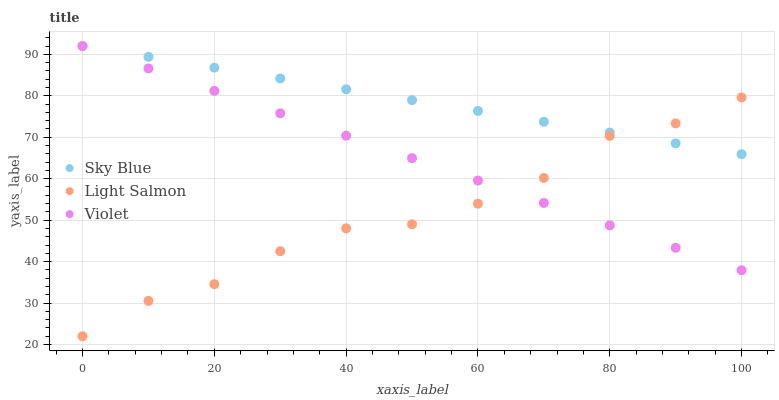Does Light Salmon have the minimum area under the curve?
Answer yes or no. Yes. Does Sky Blue have the maximum area under the curve?
Answer yes or no. Yes. Does Violet have the minimum area under the curve?
Answer yes or no. No. Does Violet have the maximum area under the curve?
Answer yes or no. No. Is Violet the smoothest?
Answer yes or no. Yes. Is Light Salmon the roughest?
Answer yes or no. Yes. Is Light Salmon the smoothest?
Answer yes or no. No. Is Violet the roughest?
Answer yes or no. No. Does Light Salmon have the lowest value?
Answer yes or no. Yes. Does Violet have the lowest value?
Answer yes or no. No. Does Violet have the highest value?
Answer yes or no. Yes. Does Light Salmon have the highest value?
Answer yes or no. No. Does Light Salmon intersect Violet?
Answer yes or no. Yes. Is Light Salmon less than Violet?
Answer yes or no. No. Is Light Salmon greater than Violet?
Answer yes or no. No. 